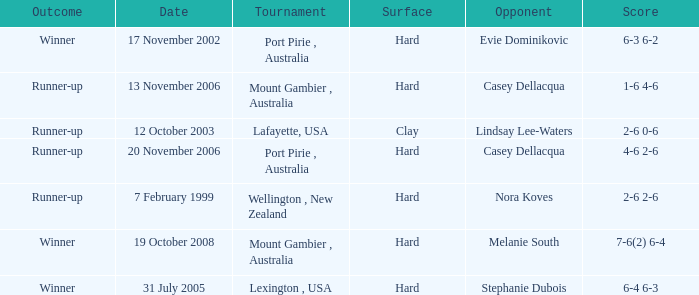Which Opponent is on 17 november 2002? Evie Dominikovic. 